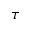<formula> <loc_0><loc_0><loc_500><loc_500>\tau</formula> 